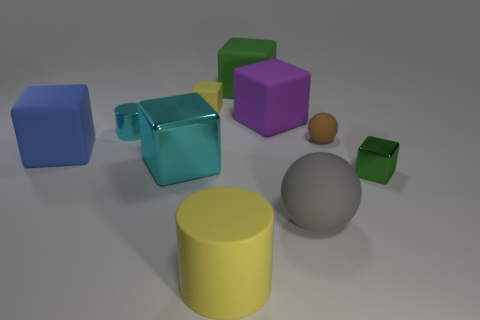Do the tiny yellow rubber object and the blue matte object that is on the left side of the tiny rubber sphere have the same shape?
Your answer should be compact. Yes. There is a yellow thing that is left of the yellow rubber cylinder; does it have the same size as the tiny cyan object?
Your answer should be compact. Yes. There is a gray thing that is the same size as the yellow cylinder; what shape is it?
Your response must be concise. Sphere. Is the tiny yellow object the same shape as the purple object?
Give a very brief answer. Yes. What number of other large objects have the same shape as the green metallic thing?
Your answer should be compact. 4. There is a purple thing; how many big things are in front of it?
Your answer should be compact. 4. Do the sphere that is behind the gray rubber sphere and the tiny cylinder have the same color?
Give a very brief answer. No. What number of green objects have the same size as the gray ball?
Your answer should be compact. 1. The big gray object that is made of the same material as the big purple block is what shape?
Make the answer very short. Sphere. Are there any objects that have the same color as the shiny cylinder?
Ensure brevity in your answer.  Yes. 